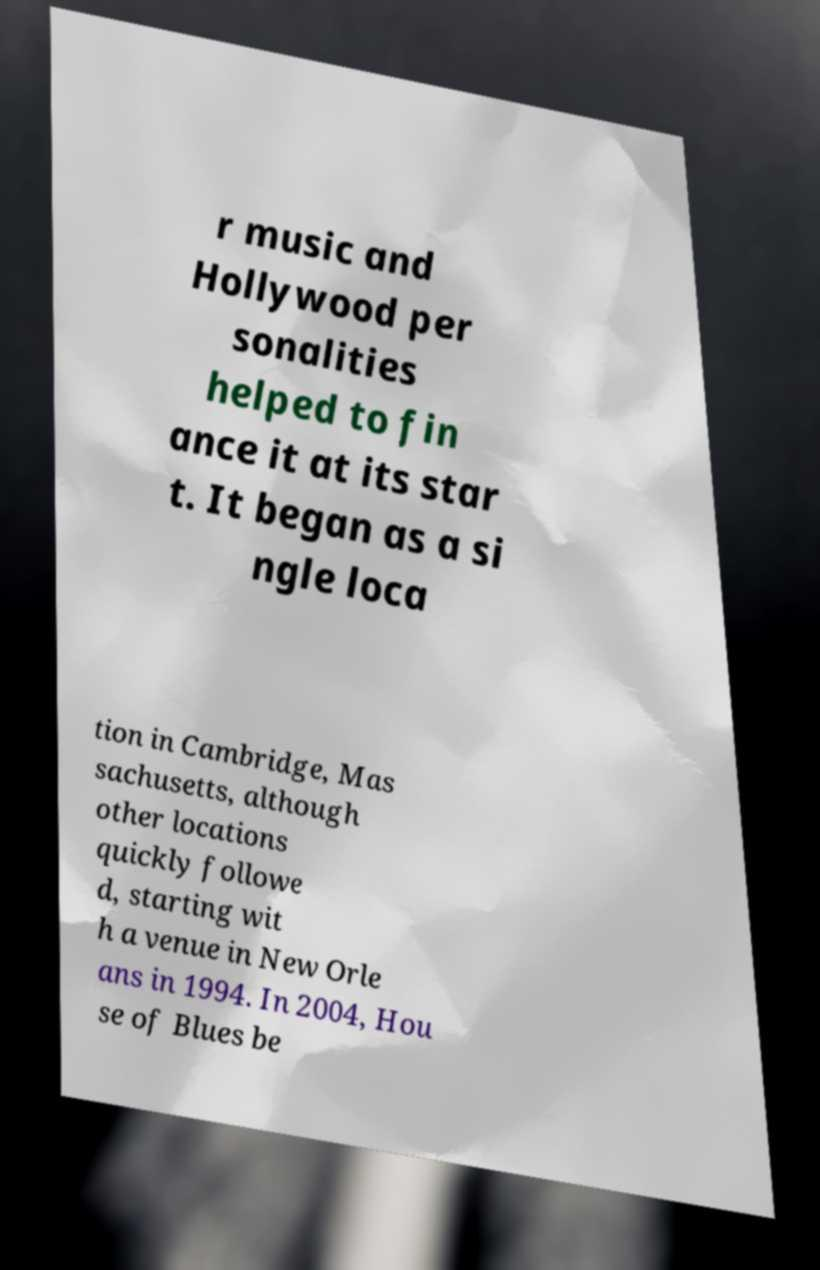What messages or text are displayed in this image? I need them in a readable, typed format. r music and Hollywood per sonalities helped to fin ance it at its star t. It began as a si ngle loca tion in Cambridge, Mas sachusetts, although other locations quickly followe d, starting wit h a venue in New Orle ans in 1994. In 2004, Hou se of Blues be 